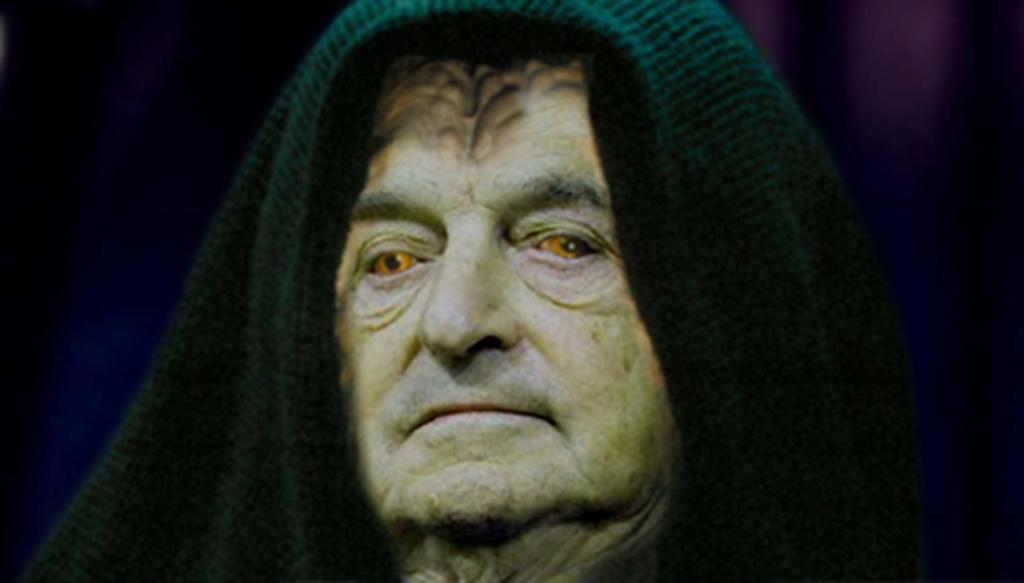Who is the main subject in the image? There is a person in the center of the image. What can be observed about the person's eyes? The person has light brown color eyes. What color is the clothing worn by the person? The person is wearing green color cloth. How many trees are on the list provided by the person in the image? There is no list or trees mentioned in the image; it only features a person with light brown eyes and green clothing. 